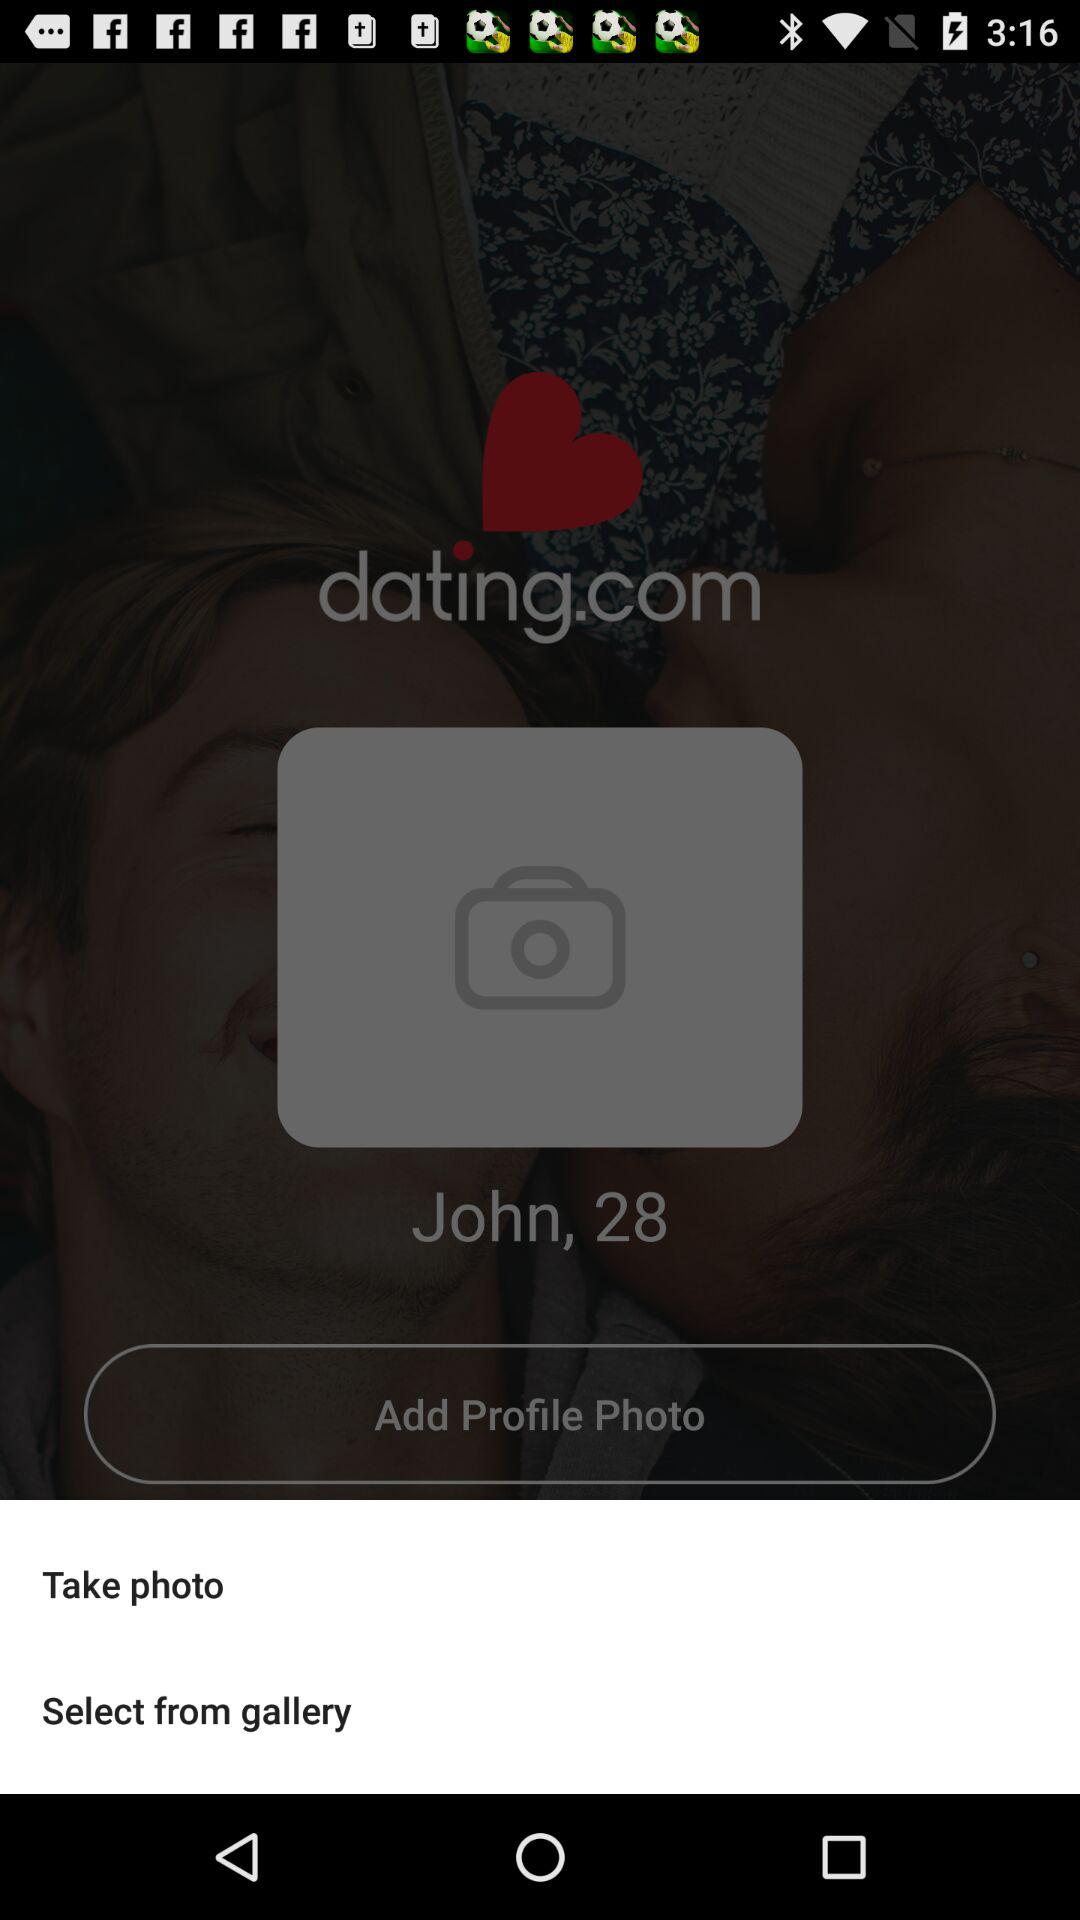What is the user name? The user name is John. 